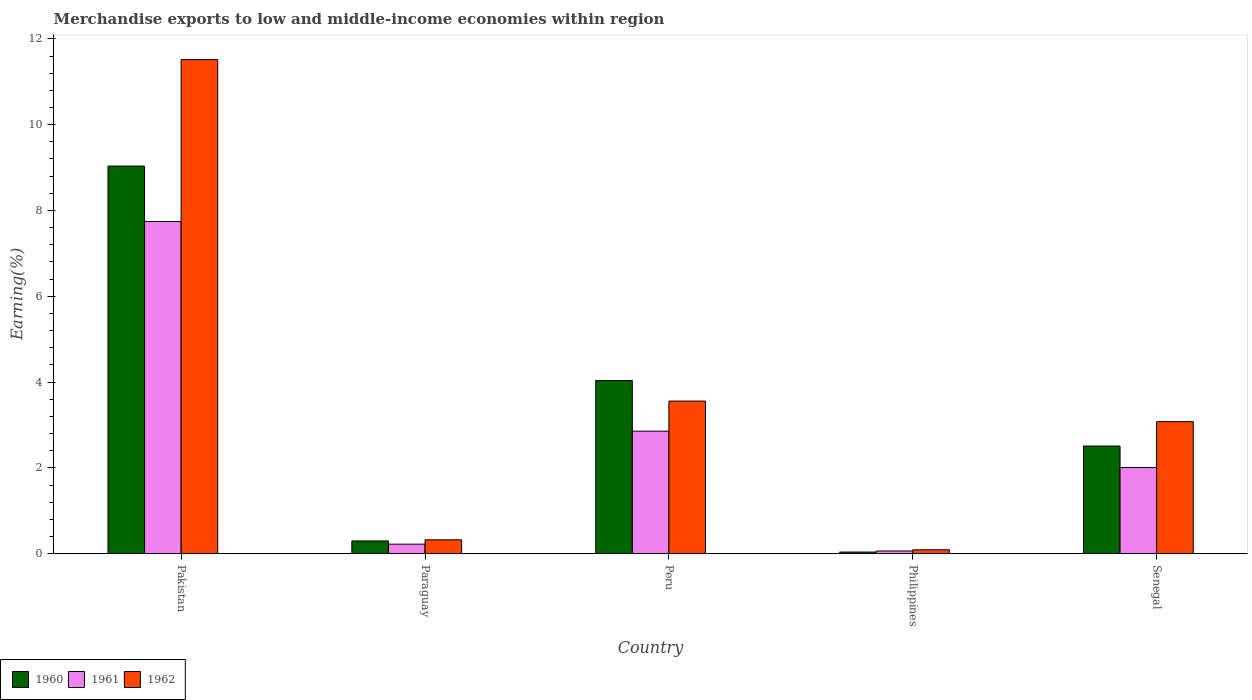How many different coloured bars are there?
Your response must be concise. 3. How many groups of bars are there?
Offer a terse response. 5. Are the number of bars on each tick of the X-axis equal?
Your answer should be very brief. Yes. What is the label of the 2nd group of bars from the left?
Offer a very short reply. Paraguay. In how many cases, is the number of bars for a given country not equal to the number of legend labels?
Offer a very short reply. 0. What is the percentage of amount earned from merchandise exports in 1962 in Paraguay?
Your response must be concise. 0.32. Across all countries, what is the maximum percentage of amount earned from merchandise exports in 1960?
Give a very brief answer. 9.04. Across all countries, what is the minimum percentage of amount earned from merchandise exports in 1960?
Ensure brevity in your answer.  0.04. In which country was the percentage of amount earned from merchandise exports in 1960 minimum?
Your answer should be very brief. Philippines. What is the total percentage of amount earned from merchandise exports in 1962 in the graph?
Provide a short and direct response. 18.56. What is the difference between the percentage of amount earned from merchandise exports in 1960 in Philippines and that in Senegal?
Ensure brevity in your answer.  -2.47. What is the difference between the percentage of amount earned from merchandise exports in 1961 in Pakistan and the percentage of amount earned from merchandise exports in 1960 in Paraguay?
Your answer should be compact. 7.45. What is the average percentage of amount earned from merchandise exports in 1961 per country?
Your answer should be compact. 2.58. What is the difference between the percentage of amount earned from merchandise exports of/in 1961 and percentage of amount earned from merchandise exports of/in 1960 in Peru?
Provide a succinct answer. -1.18. What is the ratio of the percentage of amount earned from merchandise exports in 1960 in Philippines to that in Senegal?
Keep it short and to the point. 0.01. What is the difference between the highest and the second highest percentage of amount earned from merchandise exports in 1962?
Give a very brief answer. 0.48. What is the difference between the highest and the lowest percentage of amount earned from merchandise exports in 1962?
Your response must be concise. 11.43. What does the 3rd bar from the left in Senegal represents?
Your answer should be compact. 1962. What does the 2nd bar from the right in Pakistan represents?
Offer a terse response. 1961. How many bars are there?
Give a very brief answer. 15. Are all the bars in the graph horizontal?
Make the answer very short. No. What is the difference between two consecutive major ticks on the Y-axis?
Give a very brief answer. 2. Are the values on the major ticks of Y-axis written in scientific E-notation?
Keep it short and to the point. No. Does the graph contain any zero values?
Ensure brevity in your answer.  No. Does the graph contain grids?
Provide a succinct answer. No. What is the title of the graph?
Provide a short and direct response. Merchandise exports to low and middle-income economies within region. Does "2010" appear as one of the legend labels in the graph?
Your answer should be compact. No. What is the label or title of the Y-axis?
Give a very brief answer. Earning(%). What is the Earning(%) in 1960 in Pakistan?
Provide a short and direct response. 9.04. What is the Earning(%) of 1961 in Pakistan?
Your response must be concise. 7.74. What is the Earning(%) in 1962 in Pakistan?
Your response must be concise. 11.52. What is the Earning(%) in 1960 in Paraguay?
Your answer should be compact. 0.3. What is the Earning(%) in 1961 in Paraguay?
Keep it short and to the point. 0.22. What is the Earning(%) in 1962 in Paraguay?
Your answer should be compact. 0.32. What is the Earning(%) of 1960 in Peru?
Make the answer very short. 4.04. What is the Earning(%) in 1961 in Peru?
Provide a succinct answer. 2.86. What is the Earning(%) in 1962 in Peru?
Give a very brief answer. 3.56. What is the Earning(%) in 1960 in Philippines?
Keep it short and to the point. 0.04. What is the Earning(%) in 1961 in Philippines?
Give a very brief answer. 0.06. What is the Earning(%) of 1962 in Philippines?
Offer a very short reply. 0.09. What is the Earning(%) in 1960 in Senegal?
Give a very brief answer. 2.51. What is the Earning(%) in 1961 in Senegal?
Make the answer very short. 2.01. What is the Earning(%) of 1962 in Senegal?
Your answer should be very brief. 3.08. Across all countries, what is the maximum Earning(%) in 1960?
Provide a short and direct response. 9.04. Across all countries, what is the maximum Earning(%) in 1961?
Give a very brief answer. 7.74. Across all countries, what is the maximum Earning(%) of 1962?
Make the answer very short. 11.52. Across all countries, what is the minimum Earning(%) of 1960?
Your answer should be compact. 0.04. Across all countries, what is the minimum Earning(%) of 1961?
Your answer should be very brief. 0.06. Across all countries, what is the minimum Earning(%) of 1962?
Provide a succinct answer. 0.09. What is the total Earning(%) in 1960 in the graph?
Offer a terse response. 15.91. What is the total Earning(%) of 1961 in the graph?
Provide a short and direct response. 12.89. What is the total Earning(%) in 1962 in the graph?
Provide a succinct answer. 18.56. What is the difference between the Earning(%) of 1960 in Pakistan and that in Paraguay?
Your answer should be very brief. 8.74. What is the difference between the Earning(%) in 1961 in Pakistan and that in Paraguay?
Offer a very short reply. 7.52. What is the difference between the Earning(%) of 1962 in Pakistan and that in Paraguay?
Your answer should be very brief. 11.19. What is the difference between the Earning(%) in 1960 in Pakistan and that in Peru?
Your answer should be compact. 5. What is the difference between the Earning(%) in 1961 in Pakistan and that in Peru?
Give a very brief answer. 4.89. What is the difference between the Earning(%) of 1962 in Pakistan and that in Peru?
Provide a succinct answer. 7.96. What is the difference between the Earning(%) of 1960 in Pakistan and that in Philippines?
Give a very brief answer. 9. What is the difference between the Earning(%) of 1961 in Pakistan and that in Philippines?
Provide a short and direct response. 7.68. What is the difference between the Earning(%) in 1962 in Pakistan and that in Philippines?
Offer a terse response. 11.43. What is the difference between the Earning(%) in 1960 in Pakistan and that in Senegal?
Provide a short and direct response. 6.53. What is the difference between the Earning(%) in 1961 in Pakistan and that in Senegal?
Ensure brevity in your answer.  5.74. What is the difference between the Earning(%) in 1962 in Pakistan and that in Senegal?
Keep it short and to the point. 8.44. What is the difference between the Earning(%) in 1960 in Paraguay and that in Peru?
Ensure brevity in your answer.  -3.74. What is the difference between the Earning(%) in 1961 in Paraguay and that in Peru?
Provide a short and direct response. -2.63. What is the difference between the Earning(%) of 1962 in Paraguay and that in Peru?
Provide a short and direct response. -3.23. What is the difference between the Earning(%) in 1960 in Paraguay and that in Philippines?
Ensure brevity in your answer.  0.26. What is the difference between the Earning(%) of 1961 in Paraguay and that in Philippines?
Provide a succinct answer. 0.16. What is the difference between the Earning(%) of 1962 in Paraguay and that in Philippines?
Provide a short and direct response. 0.23. What is the difference between the Earning(%) in 1960 in Paraguay and that in Senegal?
Provide a succinct answer. -2.21. What is the difference between the Earning(%) of 1961 in Paraguay and that in Senegal?
Make the answer very short. -1.79. What is the difference between the Earning(%) in 1962 in Paraguay and that in Senegal?
Offer a terse response. -2.75. What is the difference between the Earning(%) of 1960 in Peru and that in Philippines?
Your answer should be compact. 4. What is the difference between the Earning(%) of 1961 in Peru and that in Philippines?
Give a very brief answer. 2.79. What is the difference between the Earning(%) in 1962 in Peru and that in Philippines?
Make the answer very short. 3.47. What is the difference between the Earning(%) of 1960 in Peru and that in Senegal?
Your answer should be very brief. 1.53. What is the difference between the Earning(%) of 1961 in Peru and that in Senegal?
Provide a short and direct response. 0.85. What is the difference between the Earning(%) in 1962 in Peru and that in Senegal?
Make the answer very short. 0.48. What is the difference between the Earning(%) of 1960 in Philippines and that in Senegal?
Make the answer very short. -2.47. What is the difference between the Earning(%) of 1961 in Philippines and that in Senegal?
Your answer should be very brief. -1.95. What is the difference between the Earning(%) in 1962 in Philippines and that in Senegal?
Your response must be concise. -2.99. What is the difference between the Earning(%) of 1960 in Pakistan and the Earning(%) of 1961 in Paraguay?
Provide a short and direct response. 8.81. What is the difference between the Earning(%) in 1960 in Pakistan and the Earning(%) in 1962 in Paraguay?
Your response must be concise. 8.71. What is the difference between the Earning(%) of 1961 in Pakistan and the Earning(%) of 1962 in Paraguay?
Your response must be concise. 7.42. What is the difference between the Earning(%) of 1960 in Pakistan and the Earning(%) of 1961 in Peru?
Your answer should be very brief. 6.18. What is the difference between the Earning(%) in 1960 in Pakistan and the Earning(%) in 1962 in Peru?
Ensure brevity in your answer.  5.48. What is the difference between the Earning(%) of 1961 in Pakistan and the Earning(%) of 1962 in Peru?
Offer a very short reply. 4.19. What is the difference between the Earning(%) in 1960 in Pakistan and the Earning(%) in 1961 in Philippines?
Give a very brief answer. 8.97. What is the difference between the Earning(%) in 1960 in Pakistan and the Earning(%) in 1962 in Philippines?
Make the answer very short. 8.94. What is the difference between the Earning(%) of 1961 in Pakistan and the Earning(%) of 1962 in Philippines?
Offer a terse response. 7.65. What is the difference between the Earning(%) of 1960 in Pakistan and the Earning(%) of 1961 in Senegal?
Your answer should be compact. 7.03. What is the difference between the Earning(%) in 1960 in Pakistan and the Earning(%) in 1962 in Senegal?
Provide a succinct answer. 5.96. What is the difference between the Earning(%) of 1961 in Pakistan and the Earning(%) of 1962 in Senegal?
Ensure brevity in your answer.  4.67. What is the difference between the Earning(%) of 1960 in Paraguay and the Earning(%) of 1961 in Peru?
Ensure brevity in your answer.  -2.56. What is the difference between the Earning(%) of 1960 in Paraguay and the Earning(%) of 1962 in Peru?
Your response must be concise. -3.26. What is the difference between the Earning(%) in 1961 in Paraguay and the Earning(%) in 1962 in Peru?
Your answer should be very brief. -3.33. What is the difference between the Earning(%) in 1960 in Paraguay and the Earning(%) in 1961 in Philippines?
Provide a short and direct response. 0.23. What is the difference between the Earning(%) in 1960 in Paraguay and the Earning(%) in 1962 in Philippines?
Your answer should be compact. 0.21. What is the difference between the Earning(%) in 1961 in Paraguay and the Earning(%) in 1962 in Philippines?
Offer a very short reply. 0.13. What is the difference between the Earning(%) in 1960 in Paraguay and the Earning(%) in 1961 in Senegal?
Your response must be concise. -1.71. What is the difference between the Earning(%) of 1960 in Paraguay and the Earning(%) of 1962 in Senegal?
Keep it short and to the point. -2.78. What is the difference between the Earning(%) of 1961 in Paraguay and the Earning(%) of 1962 in Senegal?
Provide a short and direct response. -2.86. What is the difference between the Earning(%) of 1960 in Peru and the Earning(%) of 1961 in Philippines?
Ensure brevity in your answer.  3.97. What is the difference between the Earning(%) of 1960 in Peru and the Earning(%) of 1962 in Philippines?
Provide a short and direct response. 3.95. What is the difference between the Earning(%) in 1961 in Peru and the Earning(%) in 1962 in Philippines?
Offer a very short reply. 2.77. What is the difference between the Earning(%) of 1960 in Peru and the Earning(%) of 1961 in Senegal?
Give a very brief answer. 2.03. What is the difference between the Earning(%) in 1960 in Peru and the Earning(%) in 1962 in Senegal?
Offer a very short reply. 0.96. What is the difference between the Earning(%) of 1961 in Peru and the Earning(%) of 1962 in Senegal?
Your answer should be compact. -0.22. What is the difference between the Earning(%) in 1960 in Philippines and the Earning(%) in 1961 in Senegal?
Provide a short and direct response. -1.97. What is the difference between the Earning(%) in 1960 in Philippines and the Earning(%) in 1962 in Senegal?
Give a very brief answer. -3.04. What is the difference between the Earning(%) in 1961 in Philippines and the Earning(%) in 1962 in Senegal?
Keep it short and to the point. -3.02. What is the average Earning(%) in 1960 per country?
Provide a succinct answer. 3.18. What is the average Earning(%) of 1961 per country?
Give a very brief answer. 2.58. What is the average Earning(%) in 1962 per country?
Ensure brevity in your answer.  3.71. What is the difference between the Earning(%) in 1960 and Earning(%) in 1961 in Pakistan?
Your answer should be compact. 1.29. What is the difference between the Earning(%) in 1960 and Earning(%) in 1962 in Pakistan?
Offer a terse response. -2.48. What is the difference between the Earning(%) in 1961 and Earning(%) in 1962 in Pakistan?
Keep it short and to the point. -3.77. What is the difference between the Earning(%) of 1960 and Earning(%) of 1961 in Paraguay?
Provide a succinct answer. 0.07. What is the difference between the Earning(%) of 1960 and Earning(%) of 1962 in Paraguay?
Your answer should be very brief. -0.03. What is the difference between the Earning(%) of 1961 and Earning(%) of 1962 in Paraguay?
Your response must be concise. -0.1. What is the difference between the Earning(%) of 1960 and Earning(%) of 1961 in Peru?
Provide a succinct answer. 1.18. What is the difference between the Earning(%) of 1960 and Earning(%) of 1962 in Peru?
Make the answer very short. 0.48. What is the difference between the Earning(%) in 1961 and Earning(%) in 1962 in Peru?
Make the answer very short. -0.7. What is the difference between the Earning(%) in 1960 and Earning(%) in 1961 in Philippines?
Give a very brief answer. -0.02. What is the difference between the Earning(%) of 1960 and Earning(%) of 1962 in Philippines?
Provide a short and direct response. -0.05. What is the difference between the Earning(%) in 1961 and Earning(%) in 1962 in Philippines?
Offer a terse response. -0.03. What is the difference between the Earning(%) of 1960 and Earning(%) of 1961 in Senegal?
Your response must be concise. 0.5. What is the difference between the Earning(%) of 1960 and Earning(%) of 1962 in Senegal?
Make the answer very short. -0.57. What is the difference between the Earning(%) in 1961 and Earning(%) in 1962 in Senegal?
Provide a short and direct response. -1.07. What is the ratio of the Earning(%) in 1960 in Pakistan to that in Paraguay?
Offer a terse response. 30.47. What is the ratio of the Earning(%) of 1961 in Pakistan to that in Paraguay?
Provide a succinct answer. 34.93. What is the ratio of the Earning(%) of 1962 in Pakistan to that in Paraguay?
Make the answer very short. 35.69. What is the ratio of the Earning(%) in 1960 in Pakistan to that in Peru?
Your response must be concise. 2.24. What is the ratio of the Earning(%) in 1961 in Pakistan to that in Peru?
Your response must be concise. 2.71. What is the ratio of the Earning(%) in 1962 in Pakistan to that in Peru?
Your answer should be very brief. 3.24. What is the ratio of the Earning(%) in 1960 in Pakistan to that in Philippines?
Offer a terse response. 242.6. What is the ratio of the Earning(%) in 1961 in Pakistan to that in Philippines?
Make the answer very short. 125.83. What is the ratio of the Earning(%) of 1962 in Pakistan to that in Philippines?
Keep it short and to the point. 127.43. What is the ratio of the Earning(%) of 1960 in Pakistan to that in Senegal?
Give a very brief answer. 3.6. What is the ratio of the Earning(%) in 1961 in Pakistan to that in Senegal?
Make the answer very short. 3.86. What is the ratio of the Earning(%) in 1962 in Pakistan to that in Senegal?
Give a very brief answer. 3.74. What is the ratio of the Earning(%) of 1960 in Paraguay to that in Peru?
Provide a succinct answer. 0.07. What is the ratio of the Earning(%) in 1961 in Paraguay to that in Peru?
Ensure brevity in your answer.  0.08. What is the ratio of the Earning(%) of 1962 in Paraguay to that in Peru?
Ensure brevity in your answer.  0.09. What is the ratio of the Earning(%) of 1960 in Paraguay to that in Philippines?
Keep it short and to the point. 7.96. What is the ratio of the Earning(%) in 1961 in Paraguay to that in Philippines?
Provide a succinct answer. 3.6. What is the ratio of the Earning(%) of 1962 in Paraguay to that in Philippines?
Make the answer very short. 3.57. What is the ratio of the Earning(%) of 1960 in Paraguay to that in Senegal?
Offer a very short reply. 0.12. What is the ratio of the Earning(%) in 1961 in Paraguay to that in Senegal?
Give a very brief answer. 0.11. What is the ratio of the Earning(%) of 1962 in Paraguay to that in Senegal?
Your answer should be compact. 0.1. What is the ratio of the Earning(%) in 1960 in Peru to that in Philippines?
Make the answer very short. 108.37. What is the ratio of the Earning(%) in 1961 in Peru to that in Philippines?
Your answer should be very brief. 46.4. What is the ratio of the Earning(%) in 1962 in Peru to that in Philippines?
Keep it short and to the point. 39.35. What is the ratio of the Earning(%) in 1960 in Peru to that in Senegal?
Offer a terse response. 1.61. What is the ratio of the Earning(%) of 1961 in Peru to that in Senegal?
Your response must be concise. 1.42. What is the ratio of the Earning(%) in 1962 in Peru to that in Senegal?
Your answer should be very brief. 1.16. What is the ratio of the Earning(%) of 1960 in Philippines to that in Senegal?
Ensure brevity in your answer.  0.01. What is the ratio of the Earning(%) of 1961 in Philippines to that in Senegal?
Your answer should be compact. 0.03. What is the ratio of the Earning(%) of 1962 in Philippines to that in Senegal?
Ensure brevity in your answer.  0.03. What is the difference between the highest and the second highest Earning(%) of 1960?
Your answer should be very brief. 5. What is the difference between the highest and the second highest Earning(%) in 1961?
Provide a succinct answer. 4.89. What is the difference between the highest and the second highest Earning(%) in 1962?
Your answer should be very brief. 7.96. What is the difference between the highest and the lowest Earning(%) in 1960?
Offer a very short reply. 9. What is the difference between the highest and the lowest Earning(%) of 1961?
Provide a succinct answer. 7.68. What is the difference between the highest and the lowest Earning(%) of 1962?
Make the answer very short. 11.43. 